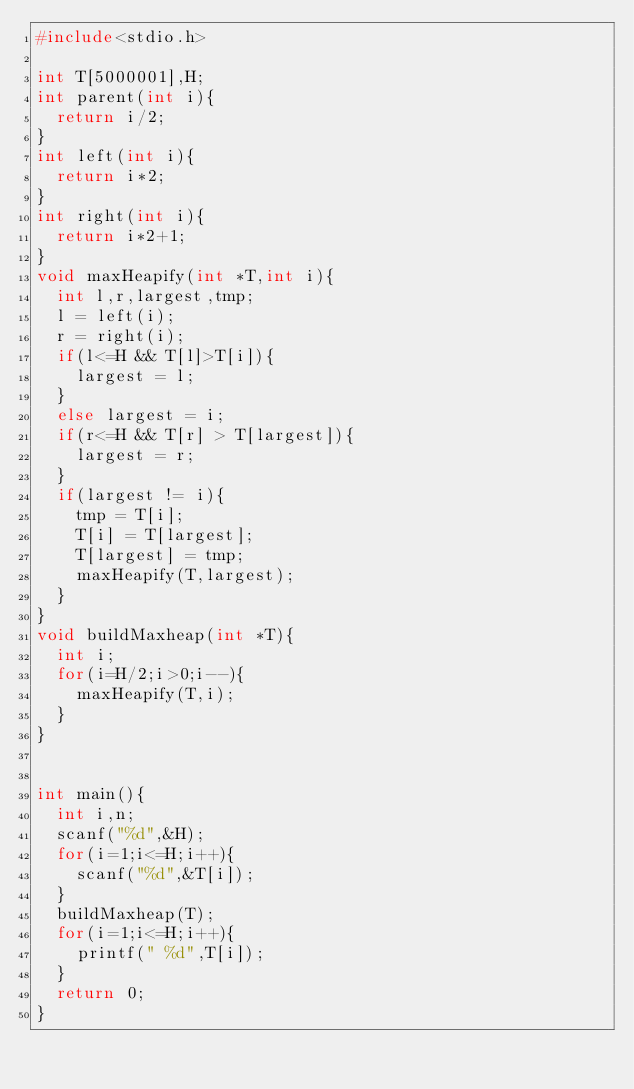<code> <loc_0><loc_0><loc_500><loc_500><_C_>#include<stdio.h>

int T[5000001],H;
int parent(int i){
  return i/2;
}
int left(int i){
  return i*2;
}
int right(int i){
  return i*2+1;
}
void maxHeapify(int *T,int i){
  int l,r,largest,tmp;
  l = left(i);
  r = right(i);
  if(l<=H && T[l]>T[i]){
    largest = l;
  }
  else largest = i;
  if(r<=H && T[r] > T[largest]){
    largest = r;
  }
  if(largest != i){
    tmp = T[i];
    T[i] = T[largest];
    T[largest] = tmp;
    maxHeapify(T,largest);
  }
}
void buildMaxheap(int *T){
  int i;
  for(i=H/2;i>0;i--){
    maxHeapify(T,i);
  }
}


int main(){
  int i,n;
  scanf("%d",&H);
  for(i=1;i<=H;i++){
    scanf("%d",&T[i]);
  }
  buildMaxheap(T);
  for(i=1;i<=H;i++){
    printf(" %d",T[i]);
  }
  return 0;
}

</code> 